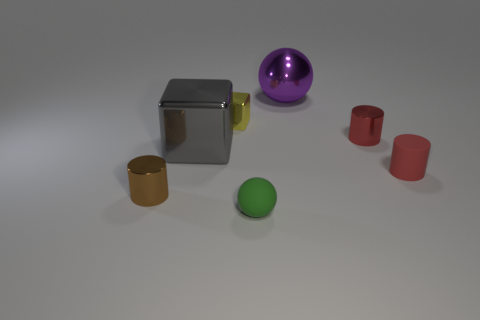There is a matte object that is right of the sphere that is in front of the small brown cylinder; how many tiny metallic blocks are in front of it?
Your answer should be very brief. 0. Is there any other thing that has the same shape as the large purple object?
Your response must be concise. Yes. How many things are either big blue matte cylinders or small red matte objects?
Give a very brief answer. 1. Does the big purple metal thing have the same shape as the rubber object that is to the left of the tiny red metallic object?
Offer a very short reply. Yes. There is a tiny object that is to the left of the big gray cube; what shape is it?
Your answer should be compact. Cylinder. Is the purple object the same shape as the small green rubber thing?
Keep it short and to the point. Yes. What is the size of the other object that is the same shape as the big gray metallic object?
Your response must be concise. Small. There is a red object that is behind the rubber cylinder; does it have the same size as the yellow block?
Provide a short and direct response. Yes. There is a thing that is in front of the gray metal block and on the right side of the tiny green rubber ball; how big is it?
Make the answer very short. Small. How many tiny things are the same color as the large block?
Your answer should be compact. 0. 